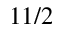Convert formula to latex. <formula><loc_0><loc_0><loc_500><loc_500>1 1 / 2</formula> 